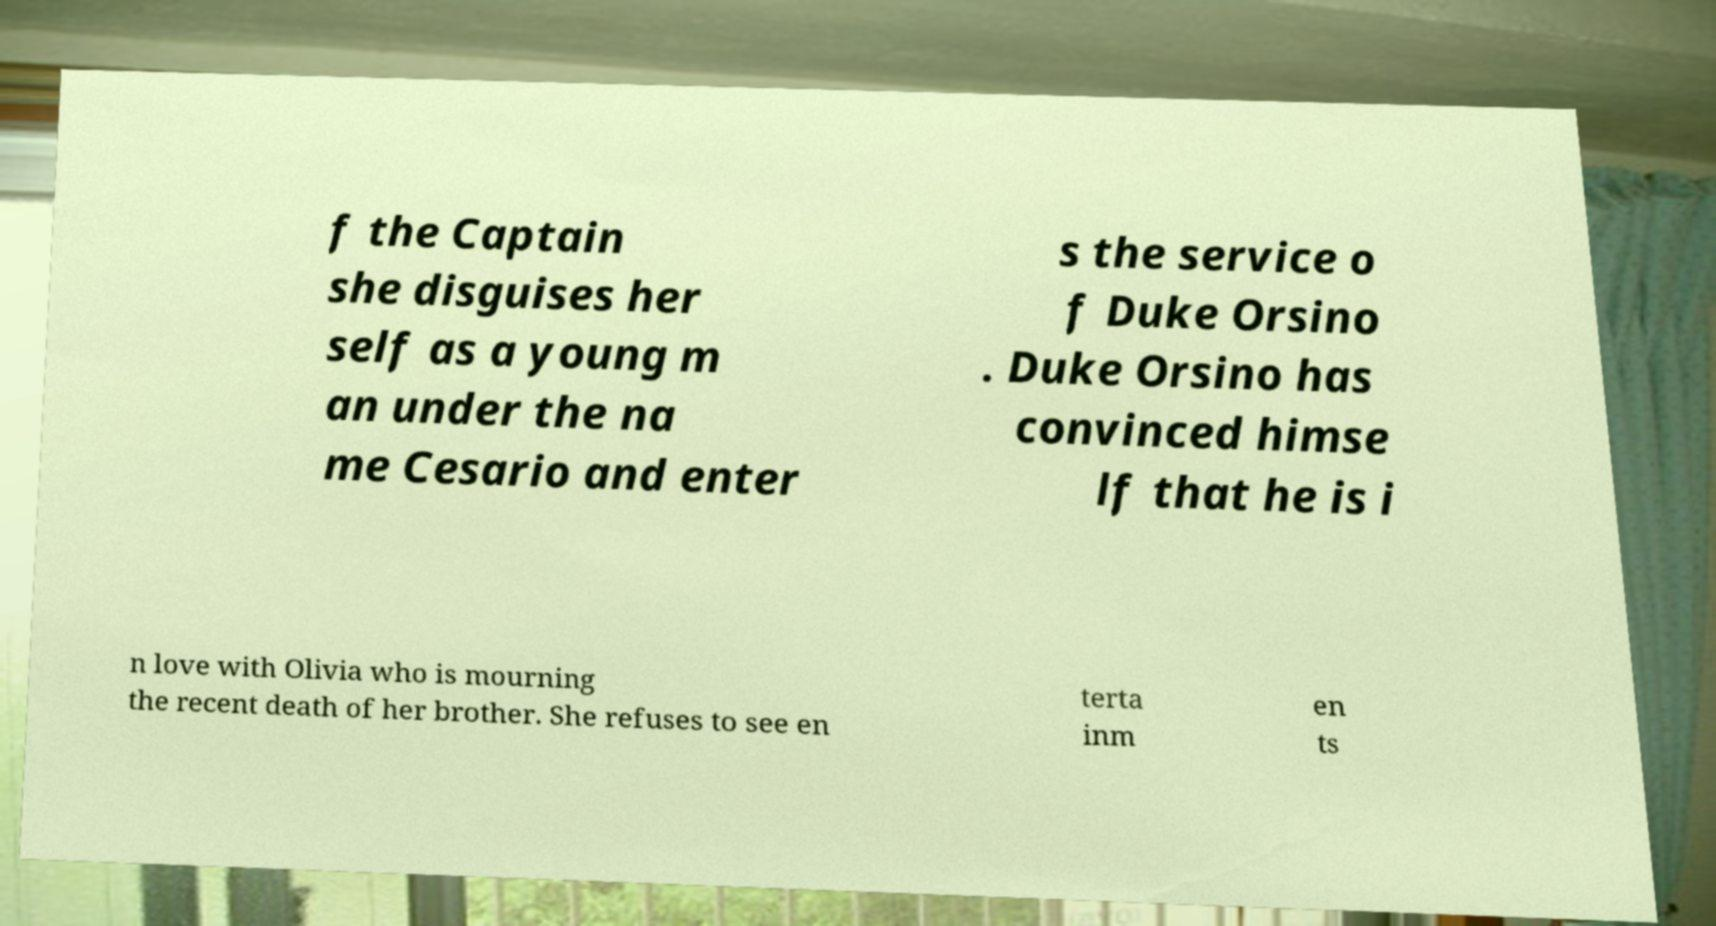There's text embedded in this image that I need extracted. Can you transcribe it verbatim? f the Captain she disguises her self as a young m an under the na me Cesario and enter s the service o f Duke Orsino . Duke Orsino has convinced himse lf that he is i n love with Olivia who is mourning the recent death of her brother. She refuses to see en terta inm en ts 